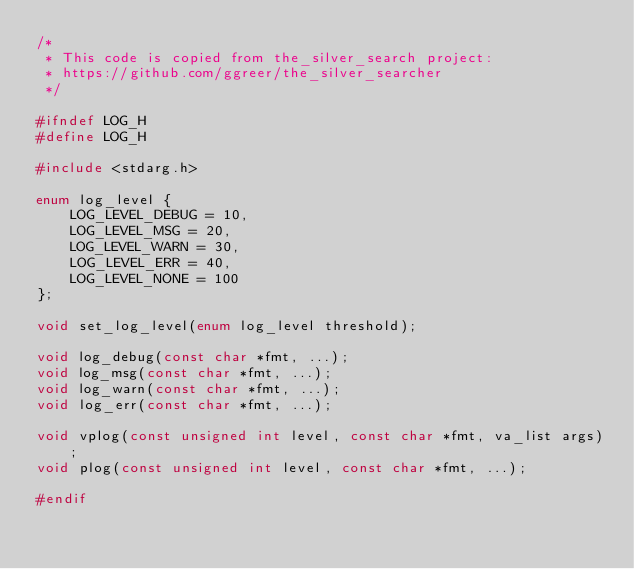Convert code to text. <code><loc_0><loc_0><loc_500><loc_500><_C_>/*
 * This code is copied from the_silver_search project:
 * https://github.com/ggreer/the_silver_searcher
 */

#ifndef LOG_H
#define LOG_H

#include <stdarg.h>

enum log_level {
    LOG_LEVEL_DEBUG = 10,
    LOG_LEVEL_MSG = 20,
    LOG_LEVEL_WARN = 30,
    LOG_LEVEL_ERR = 40,
    LOG_LEVEL_NONE = 100
};

void set_log_level(enum log_level threshold);

void log_debug(const char *fmt, ...);
void log_msg(const char *fmt, ...);
void log_warn(const char *fmt, ...);
void log_err(const char *fmt, ...);

void vplog(const unsigned int level, const char *fmt, va_list args);
void plog(const unsigned int level, const char *fmt, ...);

#endif
</code> 